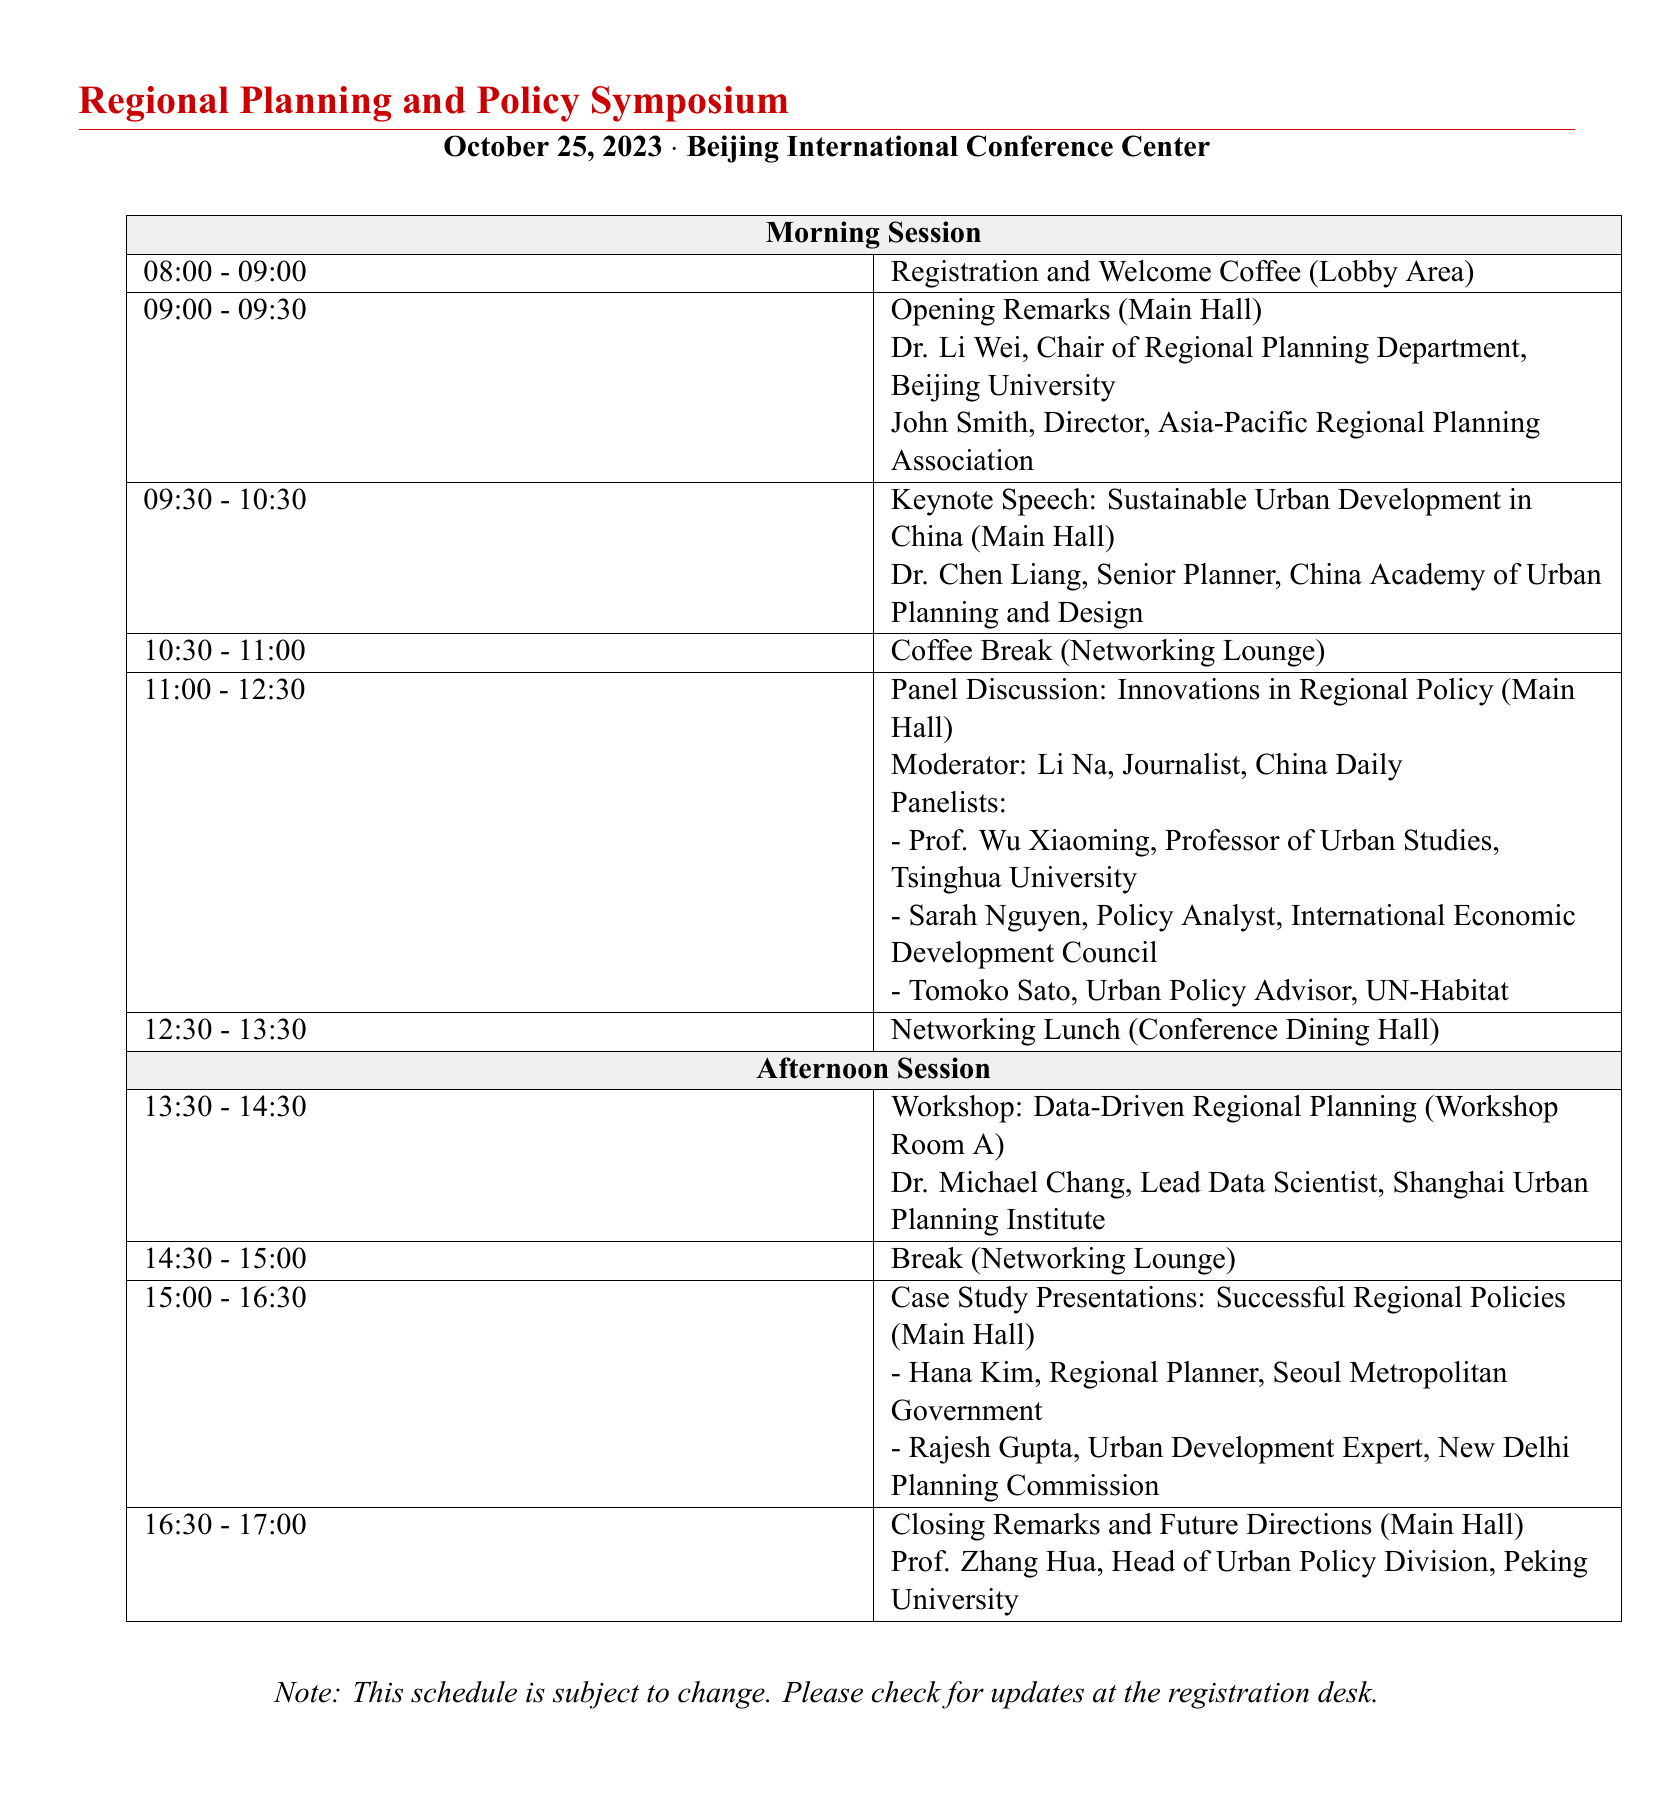What is the date of the symposium? The date is mentioned at the beginning of the document.
Answer: October 25, 2023 Who is the moderator of the panel discussion? The panel discussion moderator is listed in the morning session.
Answer: Li Na What time does the networking lunch start? The networking lunch timing is provided in the schedule.
Answer: 12:30 - 13:30 Which workshop is scheduled after the coffee break? The workshop following the coffee break is described in the afternoon session.
Answer: Data-Driven Regional Planning How many panelists are there in the panel discussion? The document lists the number of panelists in the panel discussion section.
Answer: 3 Who is giving the keynote speech? The keynote speaker's name is provided during the keynote speech time.
Answer: Dr. Chen Liang At what location will the closing remarks take place? The location for the closing remarks is specified in the afternoon session.
Answer: Main Hall What is the first event of the symposium? The first event listed is the registration and welcome coffee.
Answer: Registration and Welcome Coffee What is the title of the case study presentations? The title of the afternoon session event is described in the document.
Answer: Successful Regional Policies 